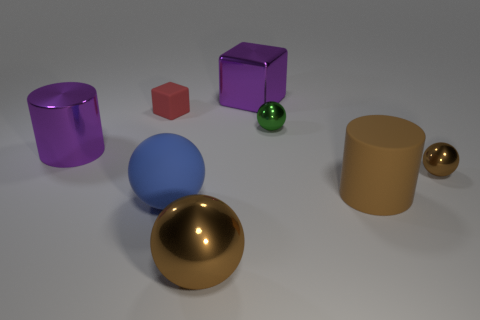Among the objects, which one is the tallest? The tallest object appears to be the purple cylinder on the left side of the image. Can you tell me more about the shapes present besides the cylinders? Aside from the two cylinders, there's a blue sphere, a small green sphere, a golden sphere, and a tiny brown cube in the composition. 